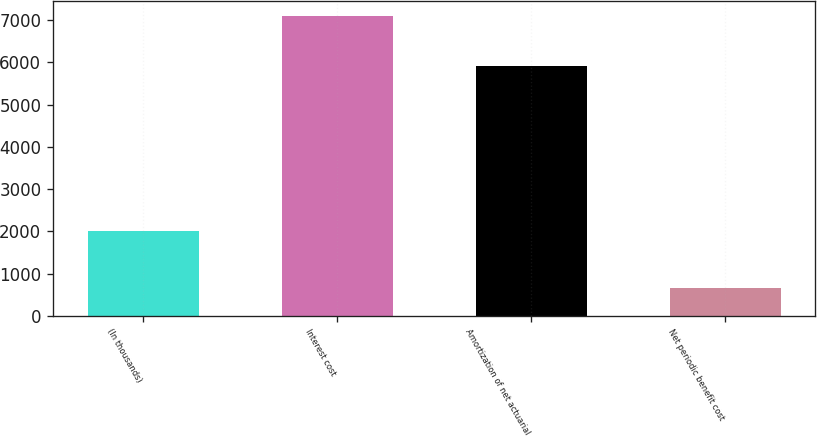Convert chart. <chart><loc_0><loc_0><loc_500><loc_500><bar_chart><fcel>(In thousands)<fcel>Interest cost<fcel>Amortization of net actuarial<fcel>Net periodic benefit cost<nl><fcel>2015<fcel>7094<fcel>5926<fcel>660<nl></chart> 